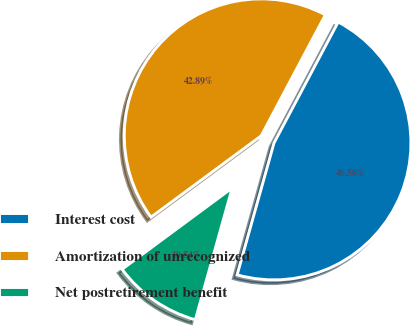<chart> <loc_0><loc_0><loc_500><loc_500><pie_chart><fcel>Interest cost<fcel>Amortization of unrecognized<fcel>Net postretirement benefit<nl><fcel>46.58%<fcel>42.89%<fcel>10.54%<nl></chart> 